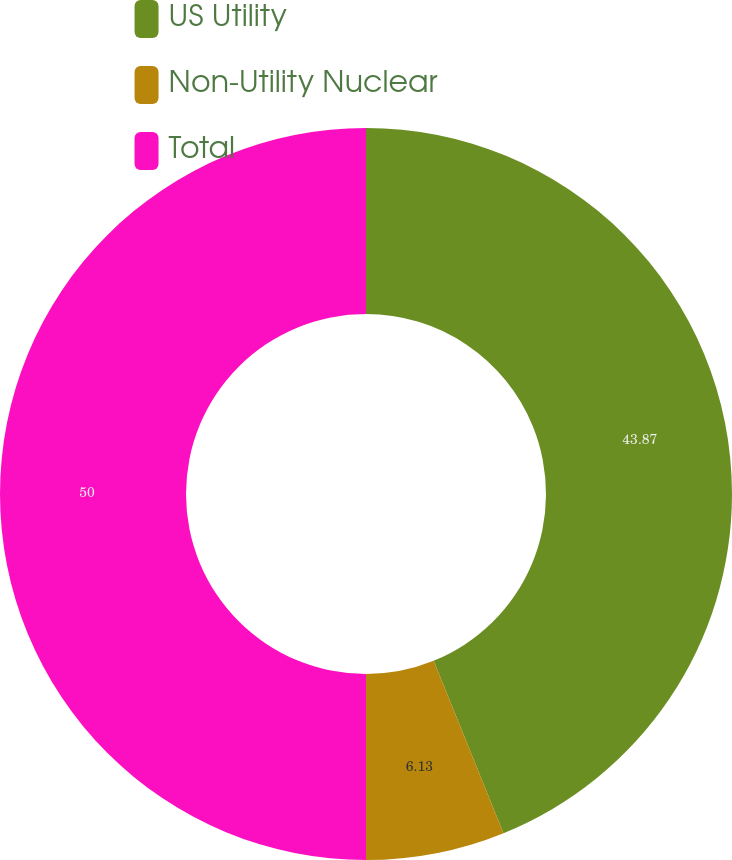Convert chart. <chart><loc_0><loc_0><loc_500><loc_500><pie_chart><fcel>US Utility<fcel>Non-Utility Nuclear<fcel>Total<nl><fcel>43.87%<fcel>6.13%<fcel>50.0%<nl></chart> 